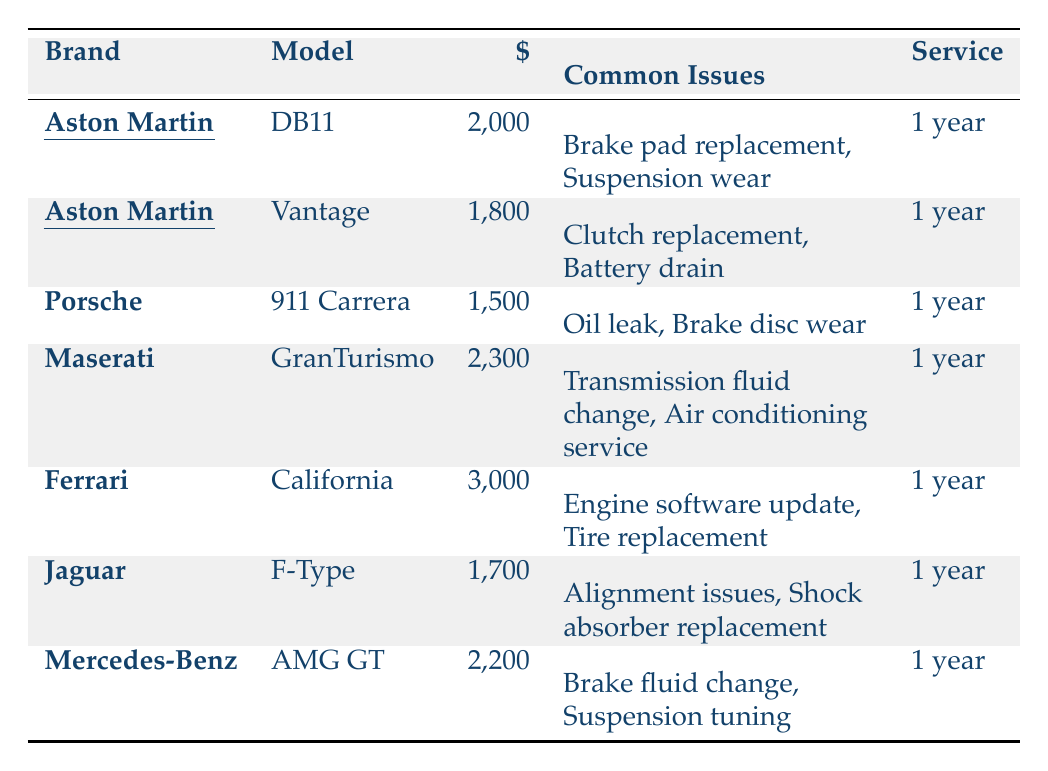What is the annual maintenance cost of the Aston Martin DB11? The table lists the annual maintenance cost for the Aston Martin DB11 as $2,000.
Answer: $2,000 What are the common issues associated with the Aston Martin Vantage? The table identifies the common issues for the Aston Martin Vantage as "Clutch replacement" and "Battery drain."
Answer: Clutch replacement, Battery drain Which car brand has the highest annual maintenance cost? According to the table, Ferrari has the highest annual maintenance cost at $3,000.
Answer: Ferrari How much more does the Maserati GranTurismo cost to maintain annually compared to the Porsche 911 Carrera? The Maserati GranTurismo costs $2,300 annually while the Porsche 911 Carrera costs $1,500 annually. The difference is $2,300 - $1,500 = $800.
Answer: $800 What is the average annual maintenance cost of all listed Aston Martin models? The two Aston Martin models listed are the DB11 ($2,000) and Vantage ($1,800). Their total is $2,000 + $1,800 = $3,800, and dividing by 2 gives an average of $3,800 / 2 = $1,900.
Answer: $1,900 Is it true that both Aston Martin models have common issues related to brake parts? The DB11 mentions "Brake pad replacement" and the Vantage does not have brake-related issues listed. Therefore, the statement is false.
Answer: No Which model has the lowest annual maintenance cost among all competitors? Looking through the table, the Porsche 911 Carrera has the lowest annual maintenance cost at $1,500.
Answer: Porsche 911 Carrera How do the common issues of Jaguar F-Type compare to those of Aston Martin models? The Jaguar F-Type has issues related to "Alignment issues" and "Shock absorber replacement," while the Aston Martin models have brake and suspension issues. The problems differ in type.
Answer: They differ What is the total annual maintenance cost for all listed cars? The total can be calculated by adding all the individual costs: $2,000 (DB11) + $1,800 (Vantage) + $1,500 (911 Carrera) + $2,300 (GranTurismo) + $3,000 (California) + $1,700 (F-Type) + $2,200 (AMG GT) = $14,500.
Answer: $14,500 Which brands have annual maintenance costs below $2,000 and what are their costs? The brands with costs below $2,000 are Porsche ($1,500), Jaguar ($1,700), and Aston Martin Vantage ($1,800).
Answer: Porsche: $1,500, Jaguar: $1,700, Aston Martin Vantage: $1,800 